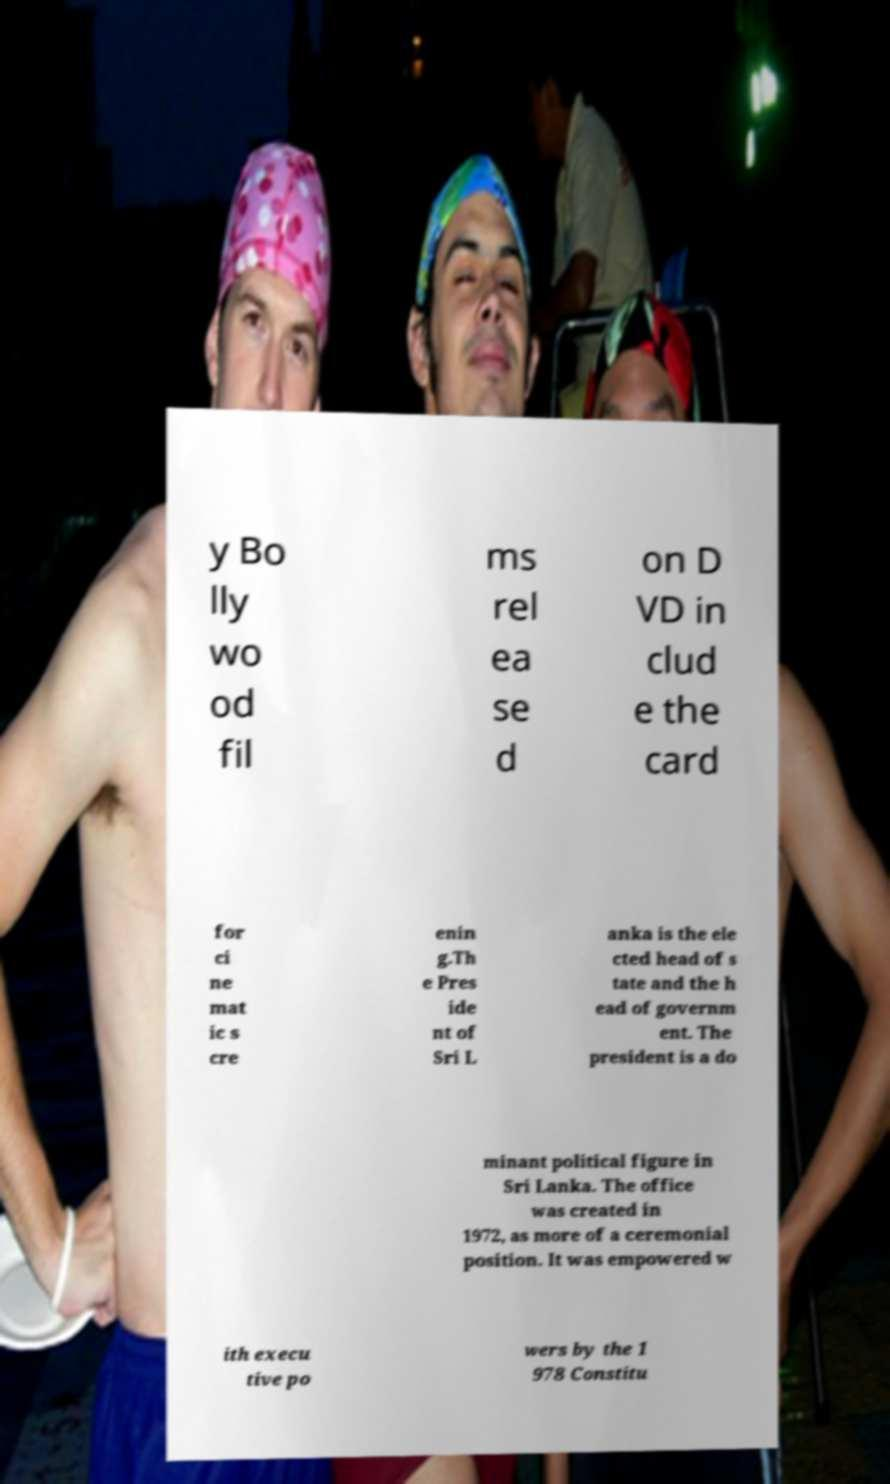Please identify and transcribe the text found in this image. y Bo lly wo od fil ms rel ea se d on D VD in clud e the card for ci ne mat ic s cre enin g.Th e Pres ide nt of Sri L anka is the ele cted head of s tate and the h ead of governm ent. The president is a do minant political figure in Sri Lanka. The office was created in 1972, as more of a ceremonial position. It was empowered w ith execu tive po wers by the 1 978 Constitu 